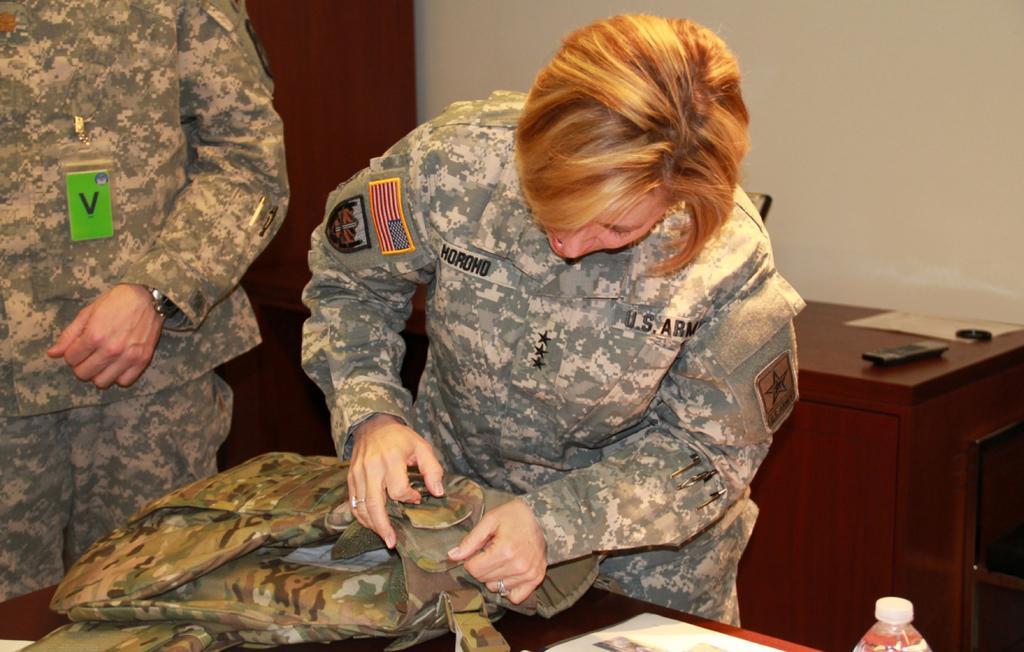Describe this image in one or two sentences. In this image we can see two people wearing uniforms. The person standing in the center is holding a bag. At the bottom there is a table and we can see a bottle, paper and a bag placed on the table. In the background there is a stand and we can see a remote, paper and an object placed on the stand. There is a wall. 